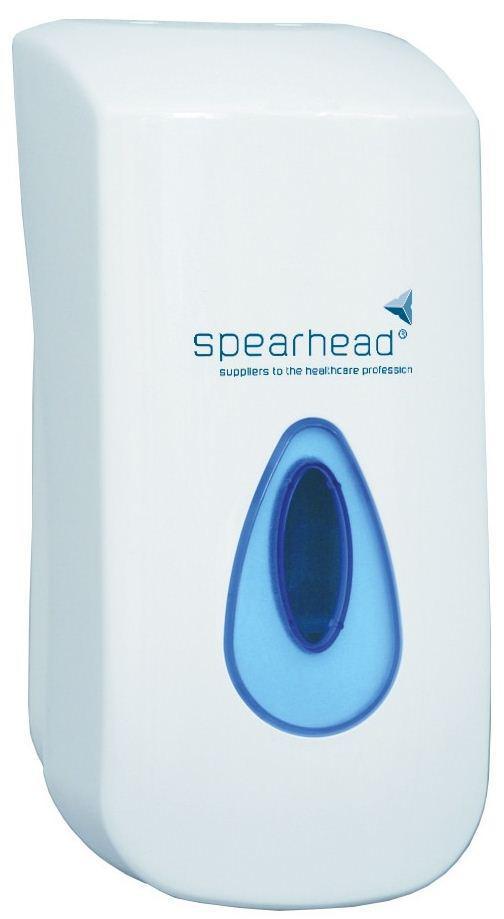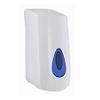The first image is the image on the left, the second image is the image on the right. Assess this claim about the two images: "The dispenser in the image on the right is sitting on wood.". Correct or not? Answer yes or no. No. The first image is the image on the left, the second image is the image on the right. For the images displayed, is the sentence "One image shows a dispenser sitting on a wood-grain surface." factually correct? Answer yes or no. No. 